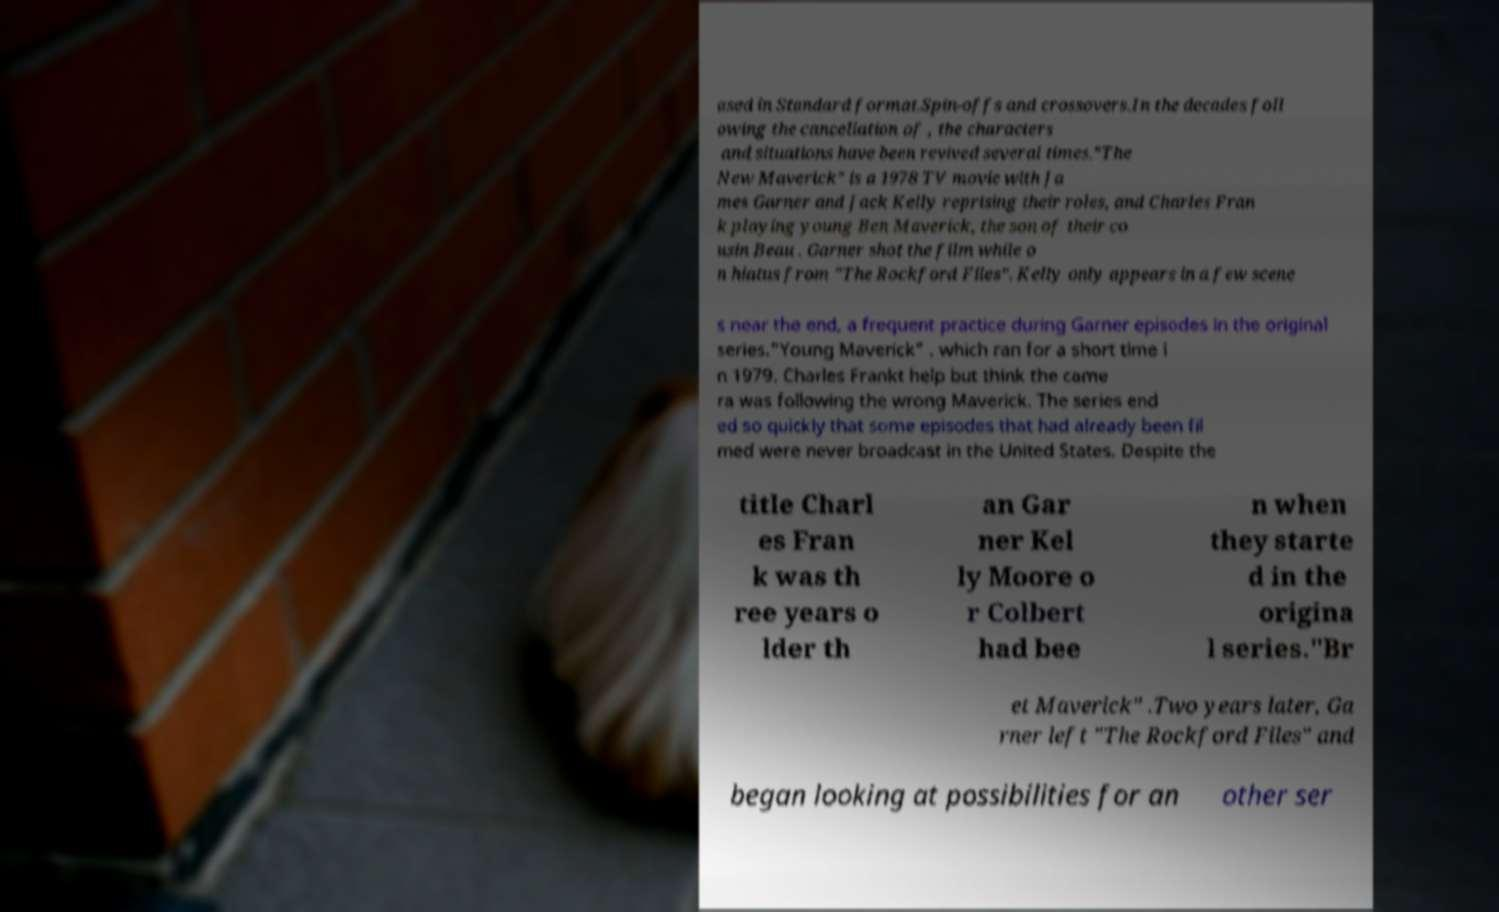I need the written content from this picture converted into text. Can you do that? ased in Standard format.Spin-offs and crossovers.In the decades foll owing the cancellation of , the characters and situations have been revived several times."The New Maverick" is a 1978 TV movie with Ja mes Garner and Jack Kelly reprising their roles, and Charles Fran k playing young Ben Maverick, the son of their co usin Beau . Garner shot the film while o n hiatus from "The Rockford Files". Kelly only appears in a few scene s near the end, a frequent practice during Garner episodes in the original series."Young Maverick" . which ran for a short time i n 1979. Charles Frankt help but think the came ra was following the wrong Maverick. The series end ed so quickly that some episodes that had already been fil med were never broadcast in the United States. Despite the title Charl es Fran k was th ree years o lder th an Gar ner Kel ly Moore o r Colbert had bee n when they starte d in the origina l series."Br et Maverick" .Two years later, Ga rner left "The Rockford Files" and began looking at possibilities for an other ser 